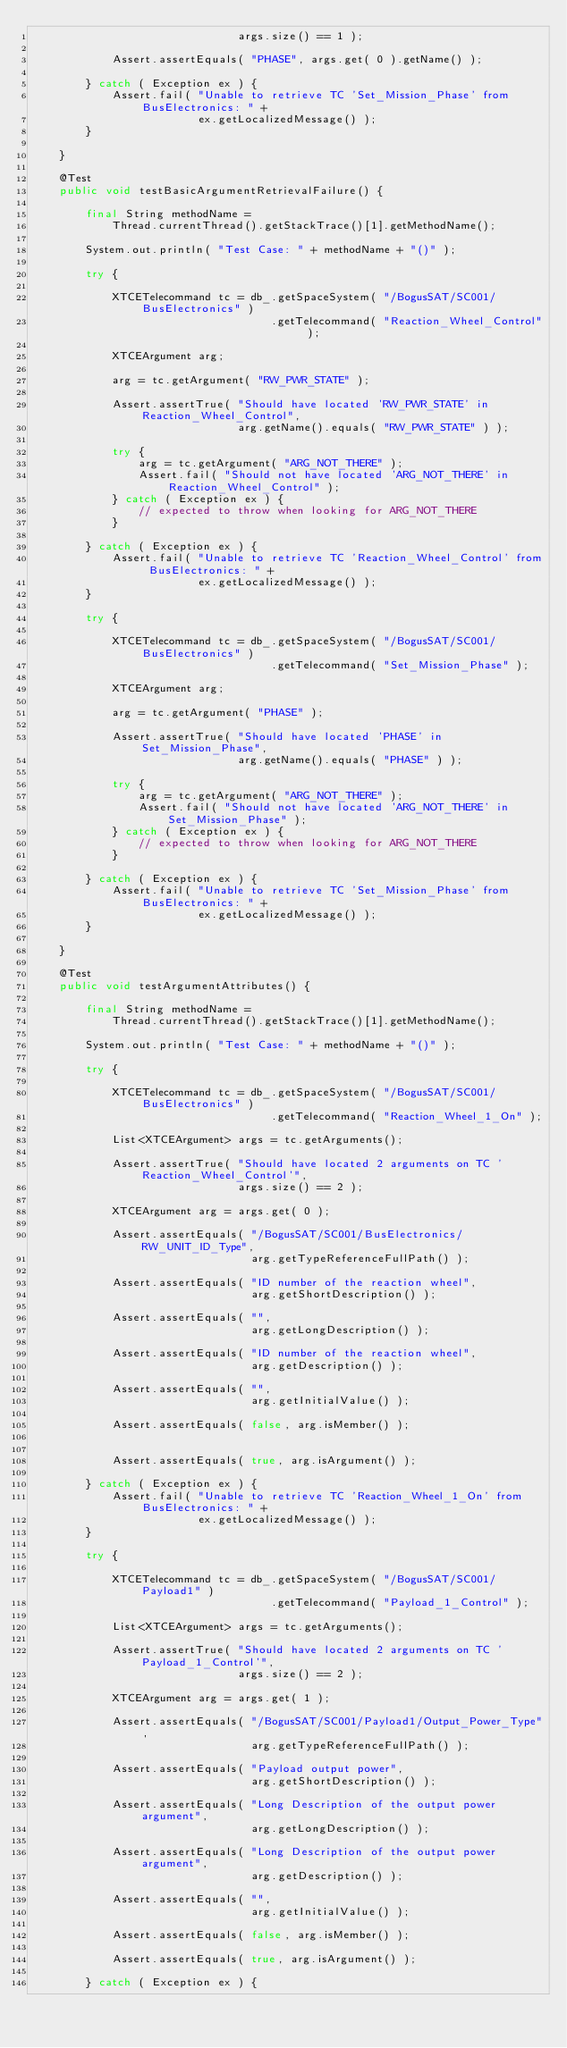<code> <loc_0><loc_0><loc_500><loc_500><_Java_>                               args.size() == 1 );

            Assert.assertEquals( "PHASE", args.get( 0 ).getName() );

        } catch ( Exception ex ) {
            Assert.fail( "Unable to retrieve TC 'Set_Mission_Phase' from BusElectronics: " +
                         ex.getLocalizedMessage() );
        }

    }

    @Test
    public void testBasicArgumentRetrievalFailure() {

        final String methodName =
            Thread.currentThread().getStackTrace()[1].getMethodName();

        System.out.println( "Test Case: " + methodName + "()" );

        try {

            XTCETelecommand tc = db_.getSpaceSystem( "/BogusSAT/SC001/BusElectronics" )
                                    .getTelecommand( "Reaction_Wheel_Control" );

            XTCEArgument arg;

            arg = tc.getArgument( "RW_PWR_STATE" );

            Assert.assertTrue( "Should have located 'RW_PWR_STATE' in Reaction_Wheel_Control",
                               arg.getName().equals( "RW_PWR_STATE" ) );

            try {
                arg = tc.getArgument( "ARG_NOT_THERE" );
                Assert.fail( "Should not have located 'ARG_NOT_THERE' in Reaction_Wheel_Control" );
            } catch ( Exception ex ) {
                // expected to throw when looking for ARG_NOT_THERE
            }

        } catch ( Exception ex ) {
            Assert.fail( "Unable to retrieve TC 'Reaction_Wheel_Control' from BusElectronics: " +
                         ex.getLocalizedMessage() );
        }

        try {

            XTCETelecommand tc = db_.getSpaceSystem( "/BogusSAT/SC001/BusElectronics" )
                                    .getTelecommand( "Set_Mission_Phase" );

            XTCEArgument arg;

            arg = tc.getArgument( "PHASE" );

            Assert.assertTrue( "Should have located 'PHASE' in Set_Mission_Phase",
                               arg.getName().equals( "PHASE" ) );

            try {
                arg = tc.getArgument( "ARG_NOT_THERE" );
                Assert.fail( "Should not have located 'ARG_NOT_THERE' in Set_Mission_Phase" );
            } catch ( Exception ex ) {
                // expected to throw when looking for ARG_NOT_THERE
            }

        } catch ( Exception ex ) {
            Assert.fail( "Unable to retrieve TC 'Set_Mission_Phase' from BusElectronics: " +
                         ex.getLocalizedMessage() );
        }

    }

    @Test
    public void testArgumentAttributes() {

        final String methodName =
            Thread.currentThread().getStackTrace()[1].getMethodName();

        System.out.println( "Test Case: " + methodName + "()" );

        try {

            XTCETelecommand tc = db_.getSpaceSystem( "/BogusSAT/SC001/BusElectronics" )
                                    .getTelecommand( "Reaction_Wheel_1_On" );

            List<XTCEArgument> args = tc.getArguments();

            Assert.assertTrue( "Should have located 2 arguments on TC 'Reaction_Wheel_Control'",
                               args.size() == 2 );

            XTCEArgument arg = args.get( 0 );

            Assert.assertEquals( "/BogusSAT/SC001/BusElectronics/RW_UNIT_ID_Type",
                                 arg.getTypeReferenceFullPath() );

            Assert.assertEquals( "ID number of the reaction wheel",
                                 arg.getShortDescription() );

            Assert.assertEquals( "",
                                 arg.getLongDescription() );

            Assert.assertEquals( "ID number of the reaction wheel",
                                 arg.getDescription() );

            Assert.assertEquals( "",
                                 arg.getInitialValue() );

            Assert.assertEquals( false, arg.isMember() );


            Assert.assertEquals( true, arg.isArgument() );

        } catch ( Exception ex ) {
            Assert.fail( "Unable to retrieve TC 'Reaction_Wheel_1_On' from BusElectronics: " +
                         ex.getLocalizedMessage() );
        }

        try {

            XTCETelecommand tc = db_.getSpaceSystem( "/BogusSAT/SC001/Payload1" )
                                    .getTelecommand( "Payload_1_Control" );

            List<XTCEArgument> args = tc.getArguments();

            Assert.assertTrue( "Should have located 2 arguments on TC 'Payload_1_Control'",
                               args.size() == 2 );

            XTCEArgument arg = args.get( 1 );

            Assert.assertEquals( "/BogusSAT/SC001/Payload1/Output_Power_Type",
                                 arg.getTypeReferenceFullPath() );

            Assert.assertEquals( "Payload output power",
                                 arg.getShortDescription() );

            Assert.assertEquals( "Long Description of the output power argument",
                                 arg.getLongDescription() );

            Assert.assertEquals( "Long Description of the output power argument",
                                 arg.getDescription() );

            Assert.assertEquals( "",
                                 arg.getInitialValue() );

            Assert.assertEquals( false, arg.isMember() );

            Assert.assertEquals( true, arg.isArgument() );

        } catch ( Exception ex ) {</code> 